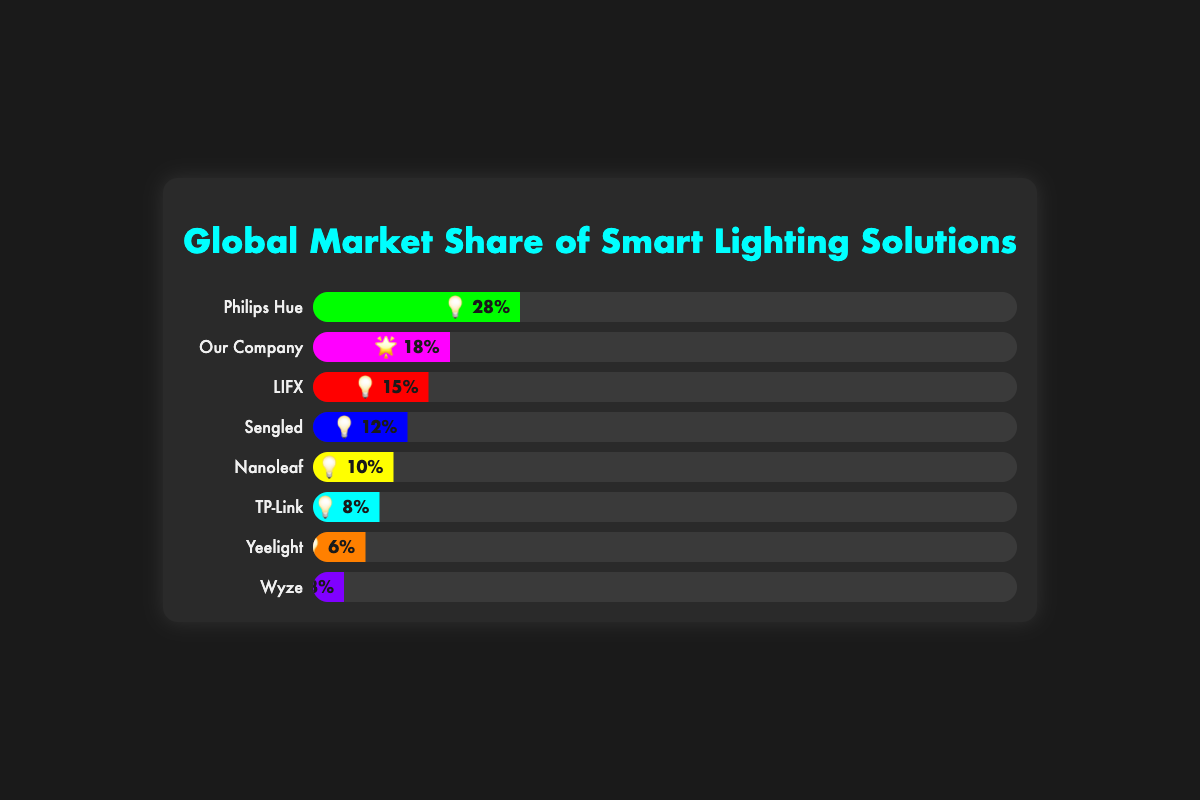What is the market share of Philips Hue? The market share of Philips Hue is directly indicated in the progress bar labeled "Philips Hue." It has a width and percentage value displayed.
Answer: 28% Which brand has the second largest market share? By visually scanning the progress bars, it is evident that our company has the second widest bar after Philips Hue.
Answer: Our Company What is the total market share of Philips Hue and Sengled combined? The individual market shares are 28% for Philips Hue and 12% for Sengled. Summing these values gives 28% + 12% = 40%.
Answer: 40% Which brand has the smallest market share? The smallest progress bar is the one labeled "Wyze."
Answer: Wyze How much greater is Our Company’s market share compared to TP-Link? The market share of Our Company is 18%, and TP-Link's market share is 8%. The difference is 18% - 8% = 10%.
Answer: 10% What is the average market share of the brands represented? Summing all market shares (28 + 15 + 12+ 10 + 18 + 8 + 6 + 3) = 100%, and there are 8 brands. The average is 100 / 8 = 12.5%.
Answer: 12.5% Which brands have a market share greater than 10%? By reviewing each progress bar, Philips Hue (28%), Our Company (18%), LIFX (15%), and Sengled (12%) have more than 10% market shares.
Answer: Philips Hue, Our Company, LIFX, Sengled What's the market share percentage for Nanoleaf, and which color represents it in the chart? The progress bar for Nanoleaf shows 10%, and its color is yellow.
Answer: 10%, yellow How much market share do brands other than Philips Hue hold together? Philips Hue has 28%, making the share for other brands 100% - 28% = 72%.
Answer: 72% Which brand has the third highest market share, and what is their exact percentage? By scanning the bar widths, LIFX is the third highest after Philips Hue and Our Company, with a market share of 15%.
Answer: LIFX, 15% 